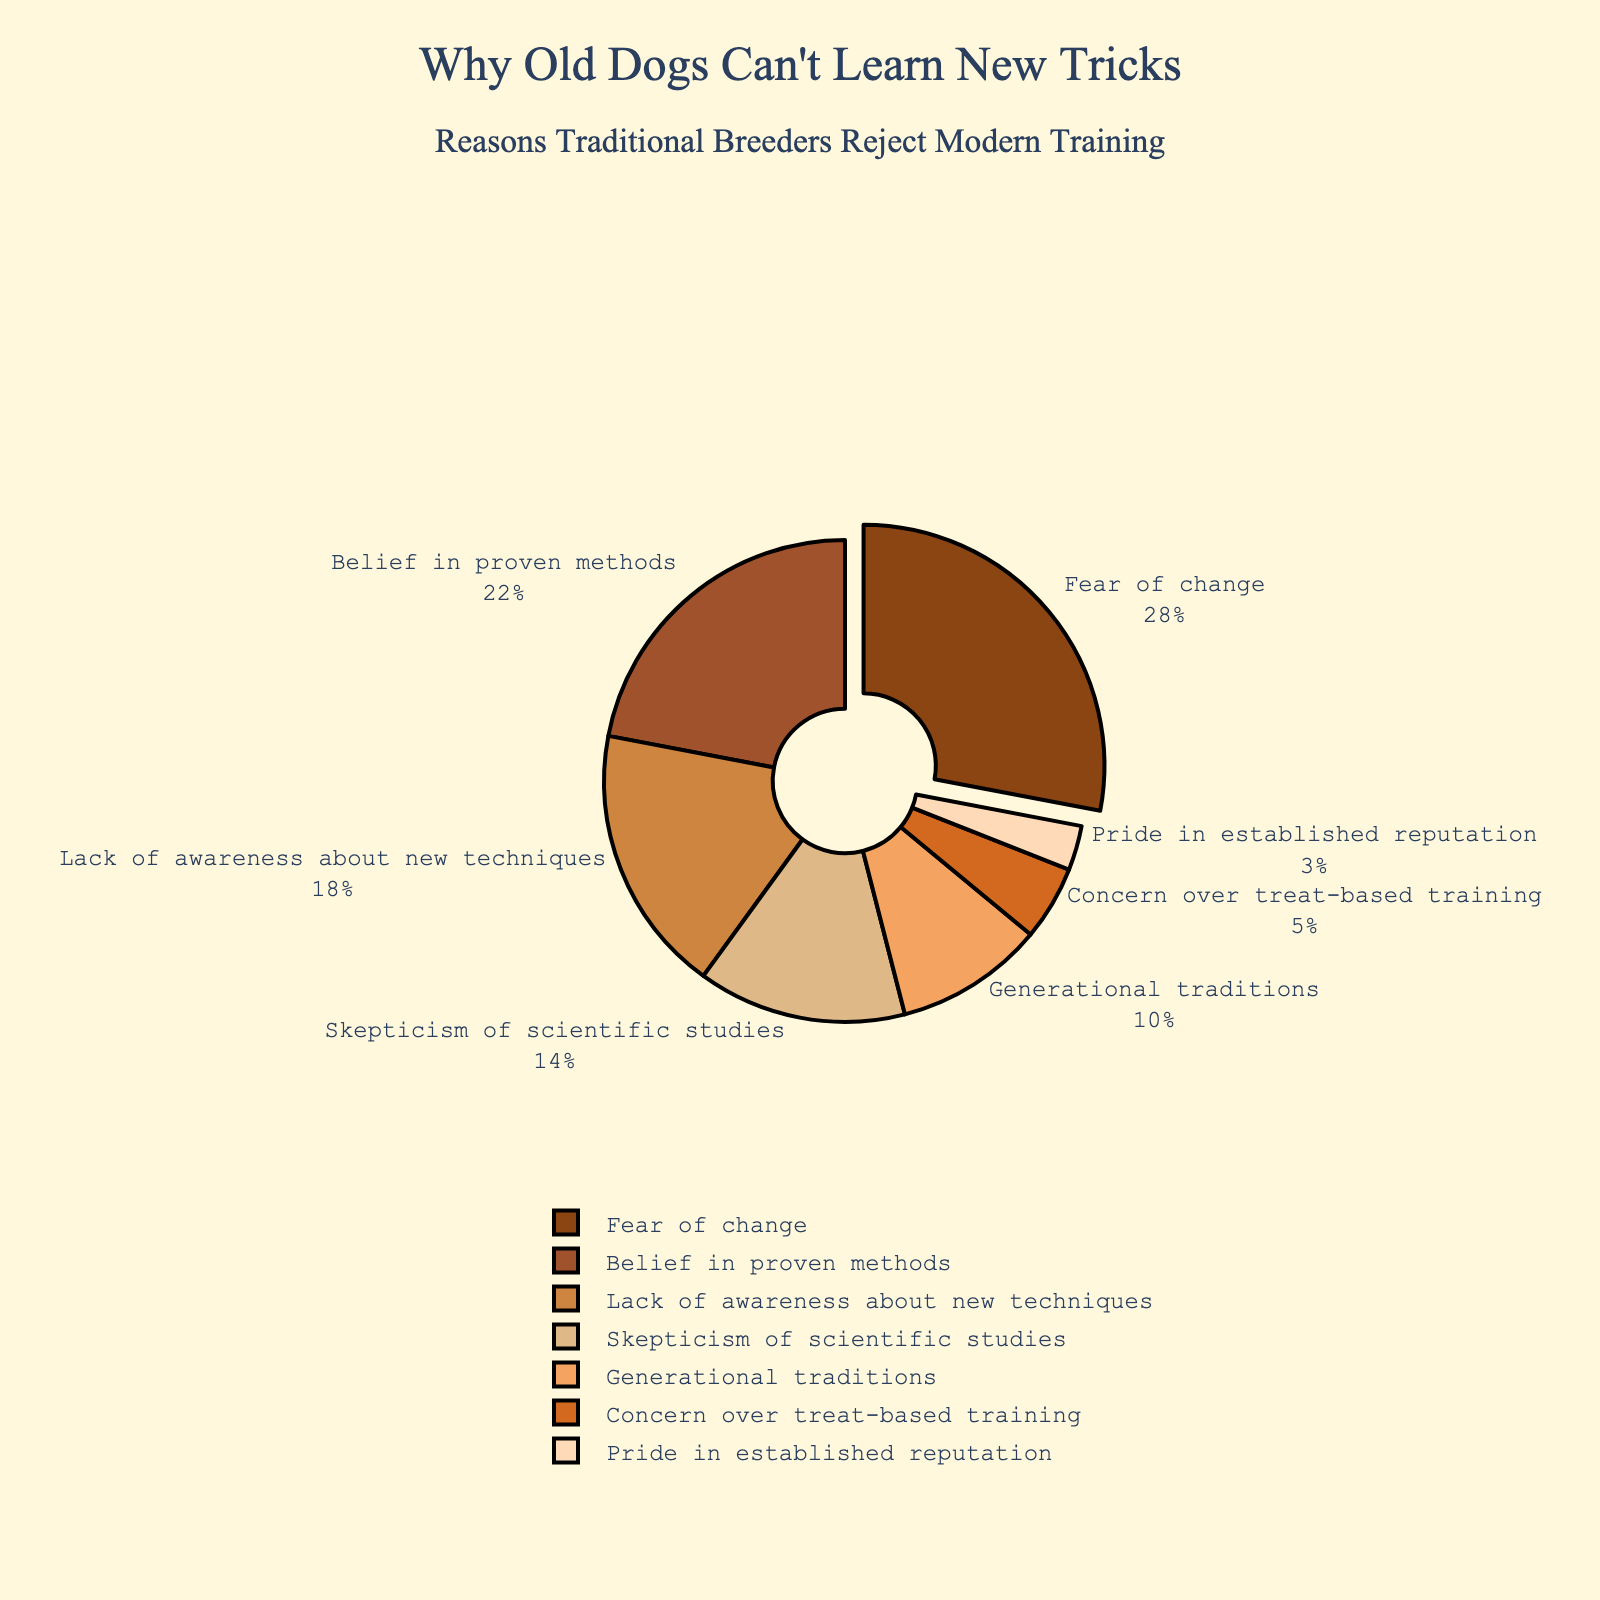what is the second most cited reason for rejecting modern training techniques? Referred to the figure, after "Fear of change," the next largest segment is "Belief in proven methods" with 22%.
Answer: Belief in proven methods How much more significant is "Fear of change" compared to "Lack of awareness about new techniques"? "Fear of change" represents 28%, and "Lack of awareness about new techniques" is 18%. The difference is 28% - 18%.
Answer: 10% What percentage of reasons listed have a value less than "Skepticism of scientific studies"? "Skepticism of scientific studies" is at 14%. Those below this threshold are "Generational traditions," "Concern over treat-based training," and "Pride in established reputation," which sum to 10% + 5% + 3%.
Answer: 18% Which reason has the smallest percentage, and what is it? The smallest segment in the pie chart is "Pride in established reputation," which is 3%.
Answer: Pride in established reputation Compare the combined percentage of "Fear of change" and "Belief in proven methods" to that of all other reasons combined. Which is greater? Add up "Fear of change" (28%) and "Belief in proven methods" (22%) for a total of 50%. The sum of the other reasons is 50%. Therefore, they are equal.
Answer: Equal How does the percentage of "Concern over treat-based training" compare to "Generational traditions"? "Concern over treat-based training" is at 5%, and "Generational traditions" is at 10%. 5% is half of 10%.
Answer: Half Identify the color associated with the smallest segment. The smallest segment, "Pride in established reputation," is depicted with the lightest color.
Answer: Light peach What is the combined percentage for reasons related to skepticism ("Skepticism of scientific studies" and "Concern over treat-based training")? Add the percentages for "Skepticism of scientific studies" (14%) and "Concern over treat-based training" (5%). The total is 14% + 5%.
Answer: 19% Given the visual representation, identify which reason stands out the most and explain why. "Fear of change" stands out as it is pulled out from the pie chart, highlighting its significance.
Answer: Fear of change 